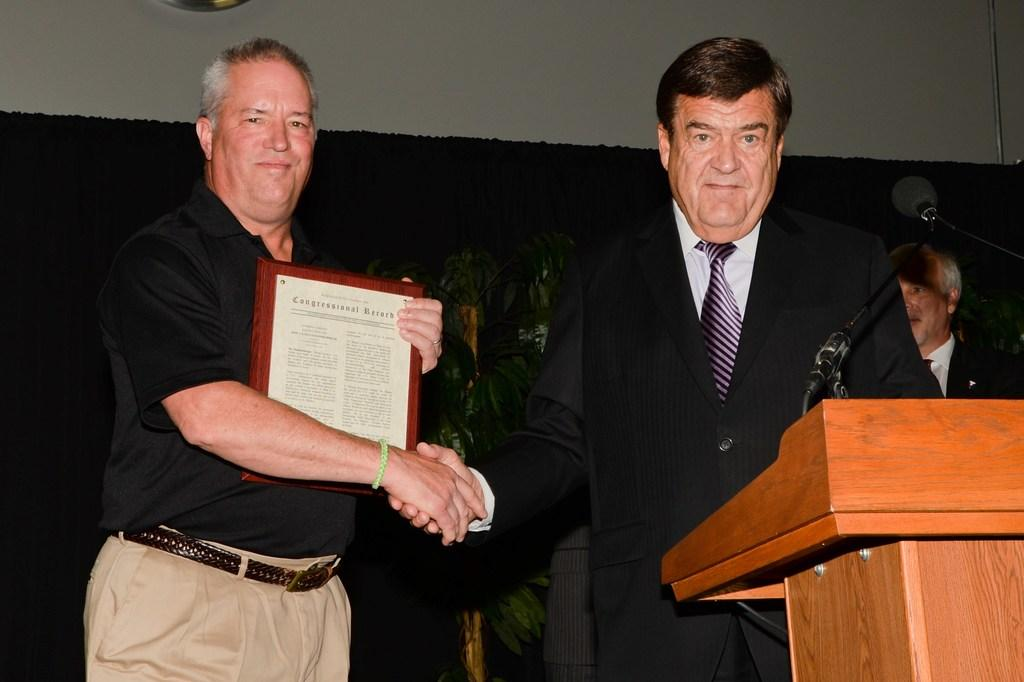What is happening in the image? There are people standing in the image. What are the people wearing? The people are wearing clothes. Can you describe the attire of one of the individuals? One person is wearing a tie. What object is present in the image that is typically used for speeches or presentations? There is a podium in the image. What equipment is visible that might be used for amplifying sound? There are microphones in the image. What type of natural elements can be seen in the image? There are plants in the image. What type of structure is present in the image that might hold a picture or photograph? There is a frame in the image. What type of personal item can be seen in the image? There is a handbag in the image. What type of fruit is being discussed by the people in the image? There is no indication in the image that a discussion about fruit, specifically quince, is taking place. 